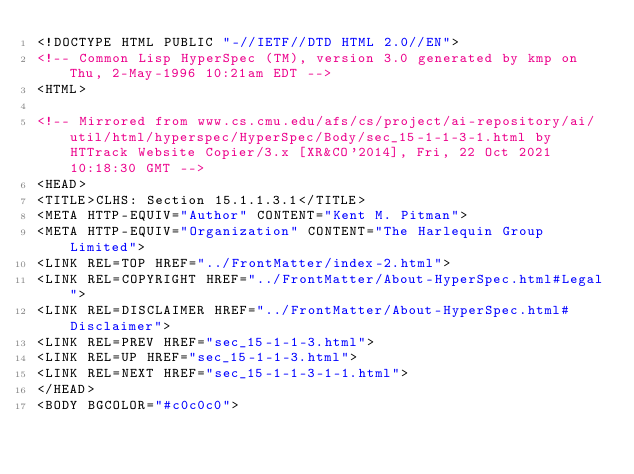<code> <loc_0><loc_0><loc_500><loc_500><_HTML_><!DOCTYPE HTML PUBLIC "-//IETF//DTD HTML 2.0//EN">
<!-- Common Lisp HyperSpec (TM), version 3.0 generated by kmp on Thu, 2-May-1996 10:21am EDT -->
<HTML>

<!-- Mirrored from www.cs.cmu.edu/afs/cs/project/ai-repository/ai/util/html/hyperspec/HyperSpec/Body/sec_15-1-1-3-1.html by HTTrack Website Copier/3.x [XR&CO'2014], Fri, 22 Oct 2021 10:18:30 GMT -->
<HEAD>
<TITLE>CLHS: Section 15.1.1.3.1</TITLE>
<META HTTP-EQUIV="Author" CONTENT="Kent M. Pitman">
<META HTTP-EQUIV="Organization" CONTENT="The Harlequin Group Limited">
<LINK REL=TOP HREF="../FrontMatter/index-2.html">
<LINK REL=COPYRIGHT HREF="../FrontMatter/About-HyperSpec.html#Legal">
<LINK REL=DISCLAIMER HREF="../FrontMatter/About-HyperSpec.html#Disclaimer">
<LINK REL=PREV HREF="sec_15-1-1-3.html">
<LINK REL=UP HREF="sec_15-1-1-3.html">
<LINK REL=NEXT HREF="sec_15-1-1-3-1-1.html">
</HEAD>
<BODY BGCOLOR="#c0c0c0"></code> 